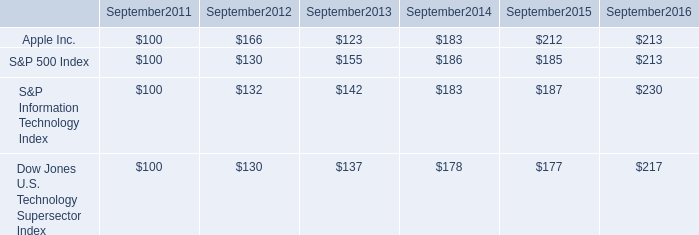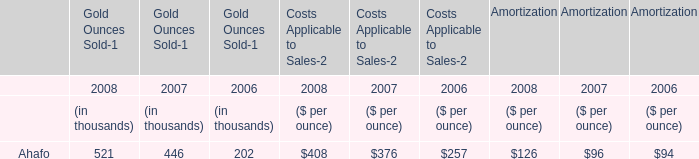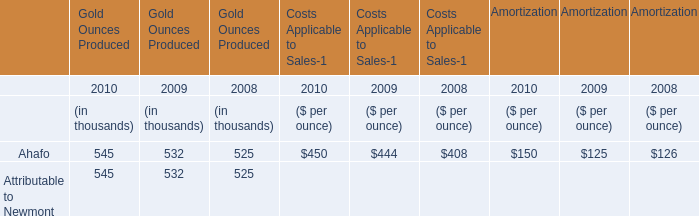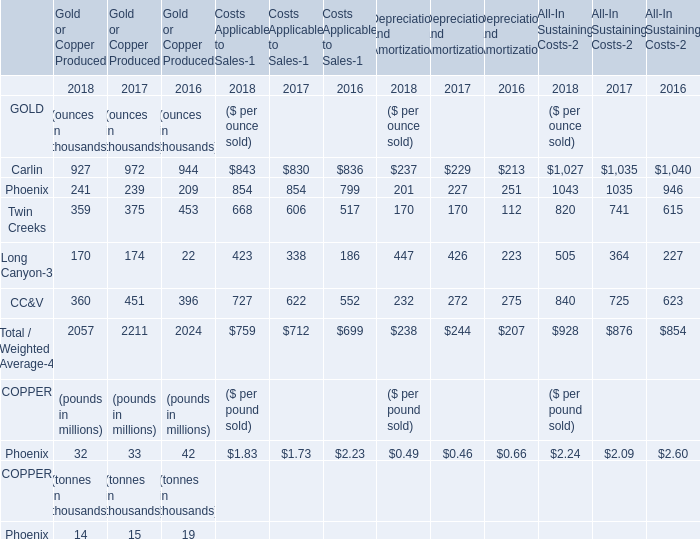what is the 6 year return of the dow jones u.s . technology supersector index? 
Computations: ((217 - 100) / 100)
Answer: 1.17. 